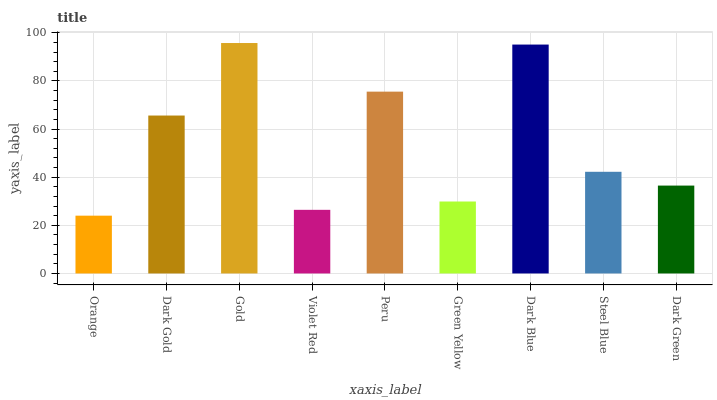Is Dark Gold the minimum?
Answer yes or no. No. Is Dark Gold the maximum?
Answer yes or no. No. Is Dark Gold greater than Orange?
Answer yes or no. Yes. Is Orange less than Dark Gold?
Answer yes or no. Yes. Is Orange greater than Dark Gold?
Answer yes or no. No. Is Dark Gold less than Orange?
Answer yes or no. No. Is Steel Blue the high median?
Answer yes or no. Yes. Is Steel Blue the low median?
Answer yes or no. Yes. Is Dark Green the high median?
Answer yes or no. No. Is Orange the low median?
Answer yes or no. No. 